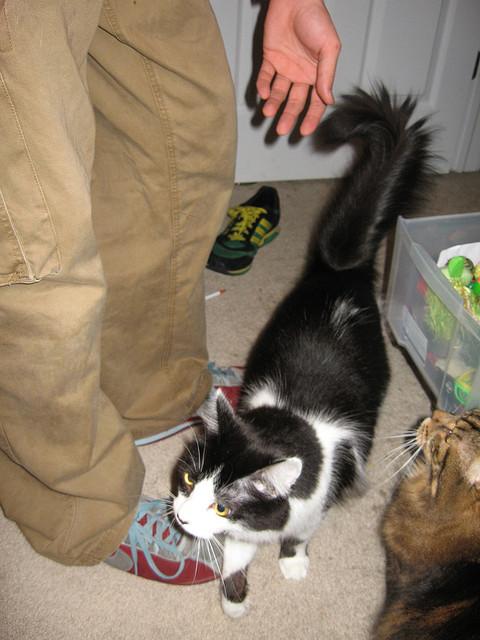Is the cat asleep?
Short answer required. No. How many tennis shoes are visible in the photo?
Answer briefly. 3. What type of cat is the one looking up at the person?
Give a very brief answer. Black and white. Do the cats seem to be expecting food?
Write a very short answer. Yes. What color is this person's pants?
Keep it brief. Tan. 